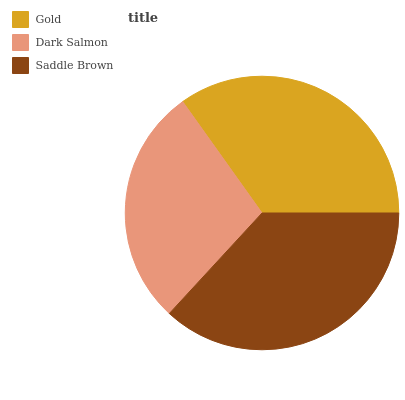Is Dark Salmon the minimum?
Answer yes or no. Yes. Is Saddle Brown the maximum?
Answer yes or no. Yes. Is Saddle Brown the minimum?
Answer yes or no. No. Is Dark Salmon the maximum?
Answer yes or no. No. Is Saddle Brown greater than Dark Salmon?
Answer yes or no. Yes. Is Dark Salmon less than Saddle Brown?
Answer yes or no. Yes. Is Dark Salmon greater than Saddle Brown?
Answer yes or no. No. Is Saddle Brown less than Dark Salmon?
Answer yes or no. No. Is Gold the high median?
Answer yes or no. Yes. Is Gold the low median?
Answer yes or no. Yes. Is Dark Salmon the high median?
Answer yes or no. No. Is Saddle Brown the low median?
Answer yes or no. No. 